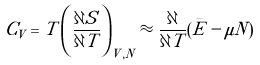Convert formula to latex. <formula><loc_0><loc_0><loc_500><loc_500>C _ { V } = T \left ( \frac { \partial S } { \partial T } \right ) _ { V , N } \approx \frac { \partial } { \partial T } ( \bar { E } - \mu N )</formula> 